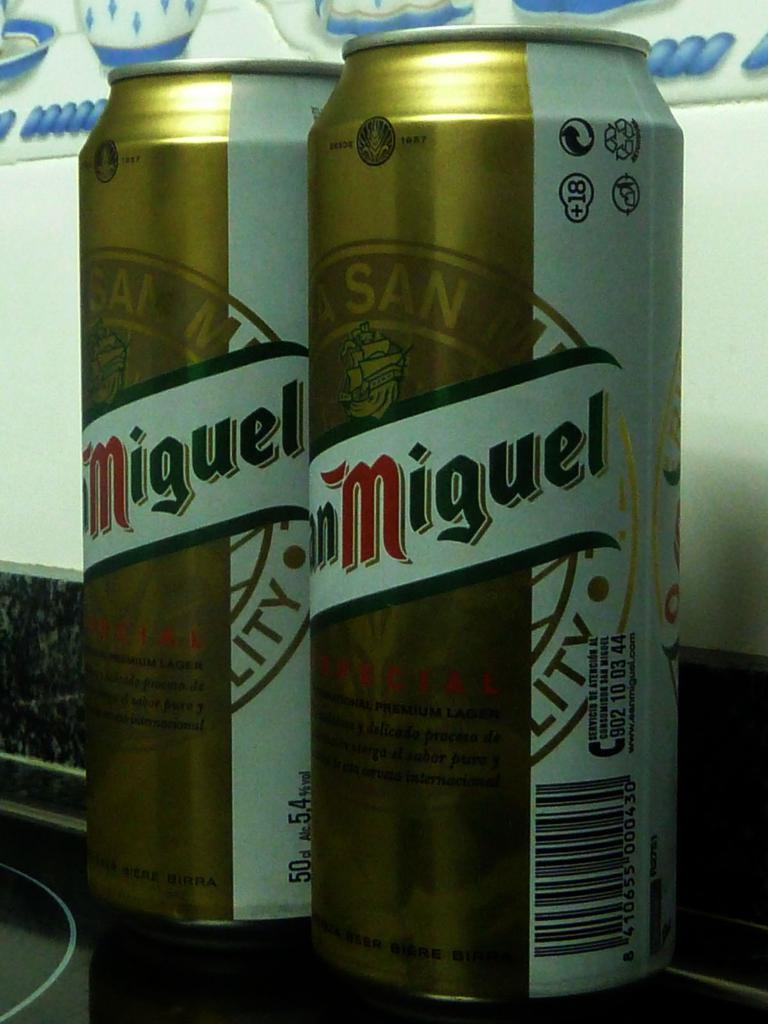<image>
Relay a brief, clear account of the picture shown. Two cans on a beverage with the name Miguel on it. 